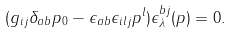Convert formula to latex. <formula><loc_0><loc_0><loc_500><loc_500>( g _ { i j } \delta _ { a b } p _ { 0 } - \epsilon _ { a b } \epsilon _ { i l j } p ^ { l } ) \epsilon ^ { b j } _ { \lambda } ( p ) = 0 .</formula> 